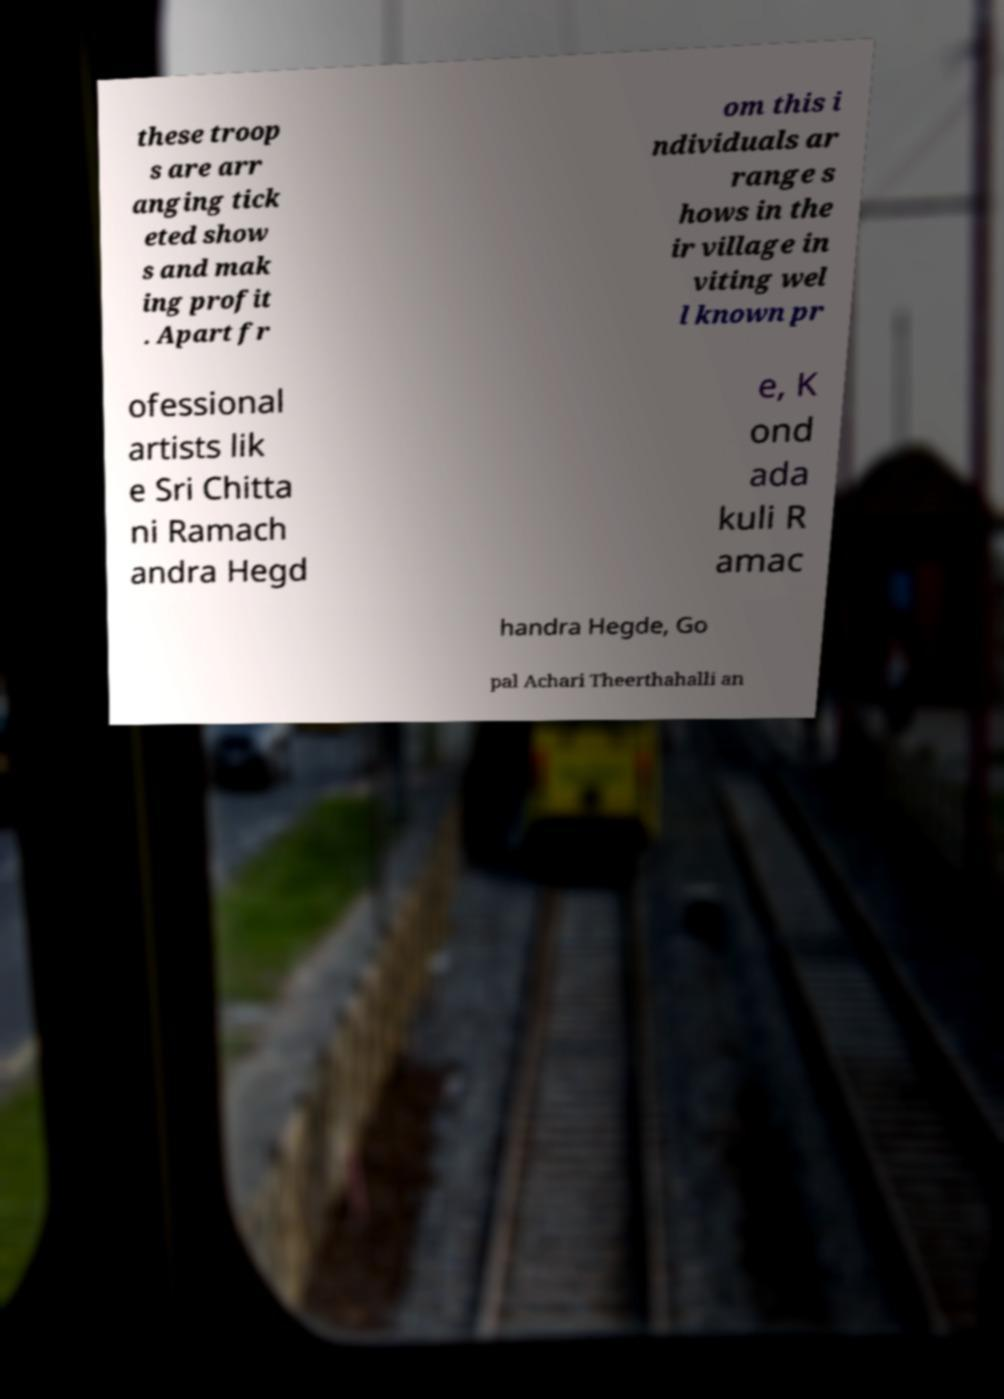Please identify and transcribe the text found in this image. these troop s are arr anging tick eted show s and mak ing profit . Apart fr om this i ndividuals ar range s hows in the ir village in viting wel l known pr ofessional artists lik e Sri Chitta ni Ramach andra Hegd e, K ond ada kuli R amac handra Hegde, Go pal Achari Theerthahalli an 